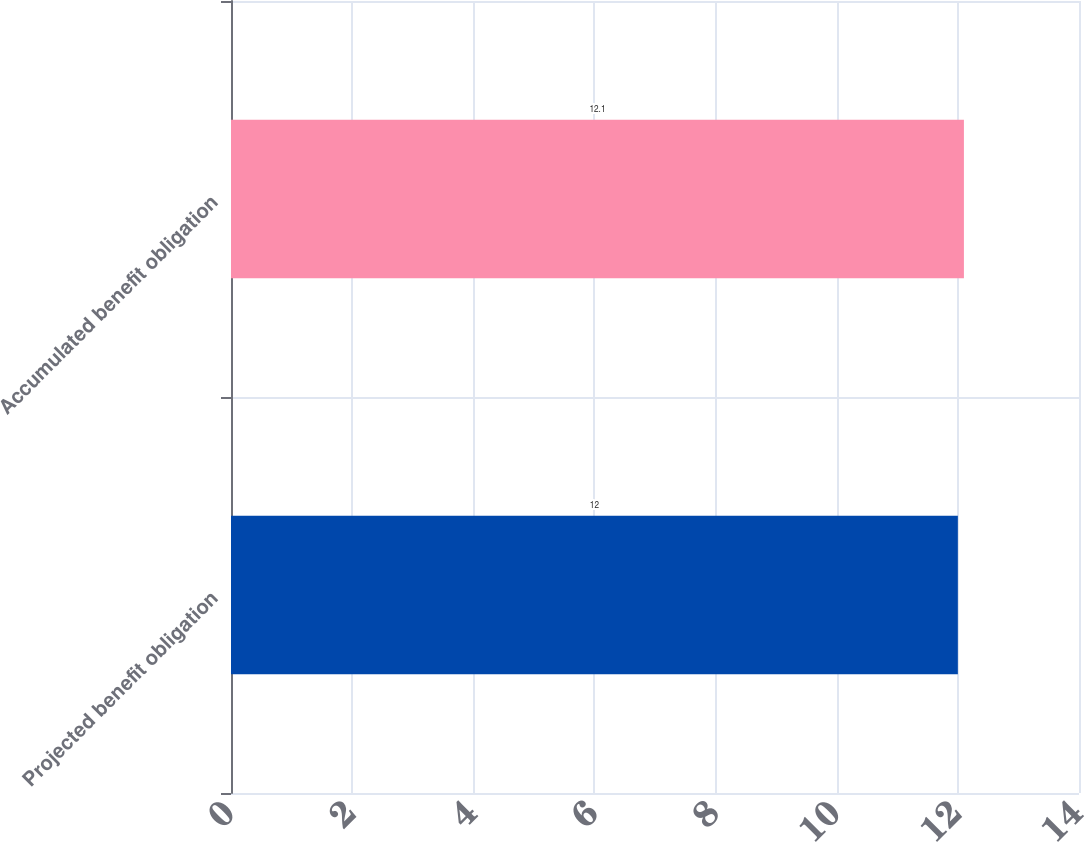Convert chart to OTSL. <chart><loc_0><loc_0><loc_500><loc_500><bar_chart><fcel>Projected benefit obligation<fcel>Accumulated benefit obligation<nl><fcel>12<fcel>12.1<nl></chart> 